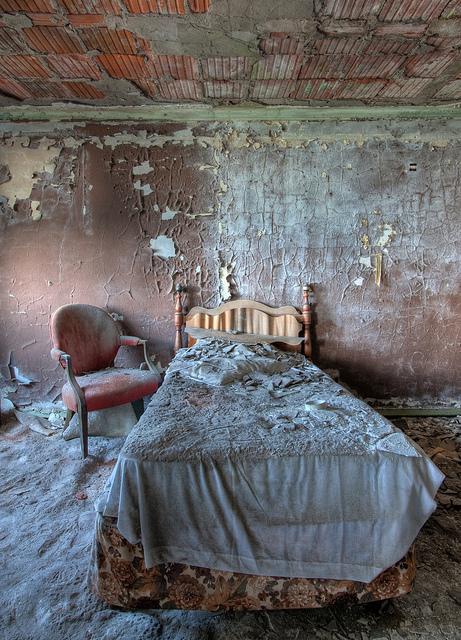Should this room be renovated?
Concise answer only. Yes. What color is the chair?
Be succinct. Red. Is the bed ready to be slept in?
Write a very short answer. No. 